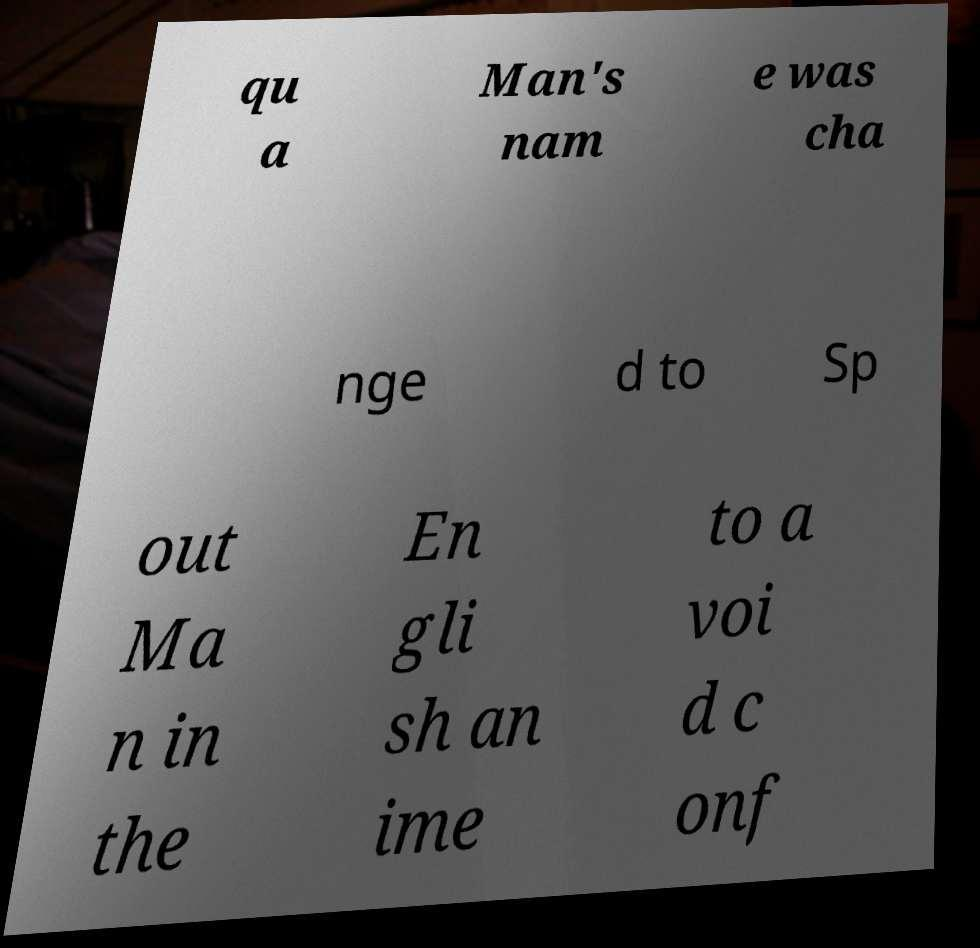What messages or text are displayed in this image? I need them in a readable, typed format. qu a Man's nam e was cha nge d to Sp out Ma n in the En gli sh an ime to a voi d c onf 